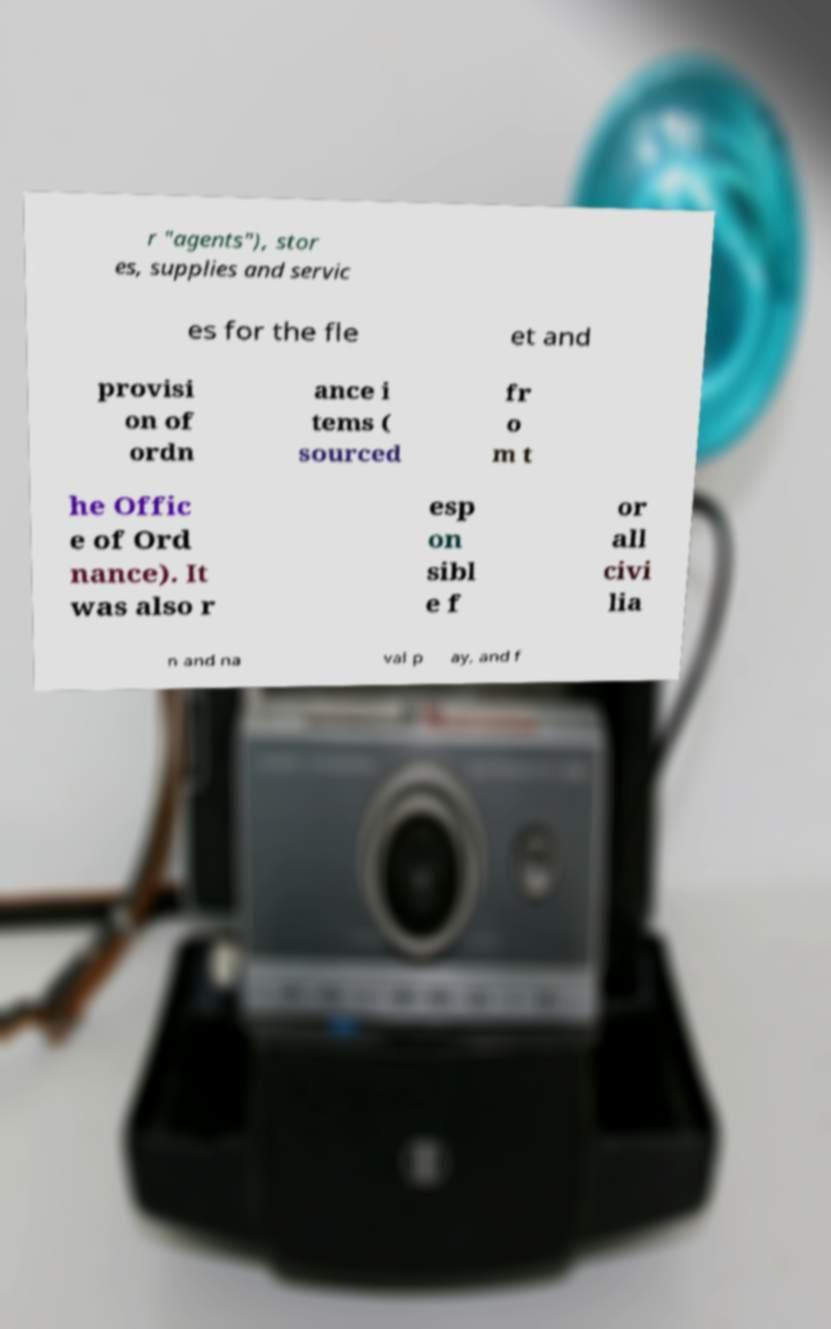Can you accurately transcribe the text from the provided image for me? r "agents"), stor es, supplies and servic es for the fle et and provisi on of ordn ance i tems ( sourced fr o m t he Offic e of Ord nance). It was also r esp on sibl e f or all civi lia n and na val p ay, and f 